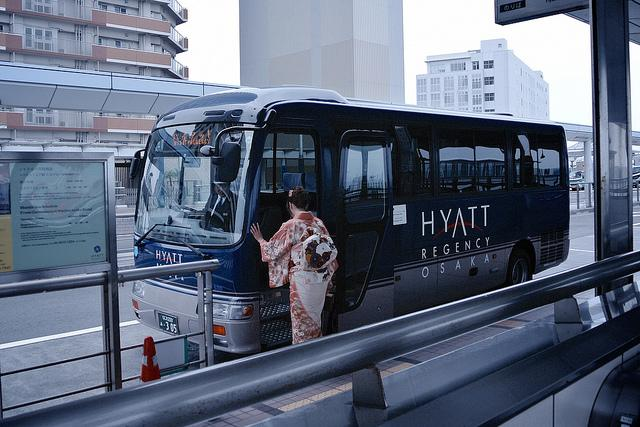In what city is this woman boarding the bus? osaka 